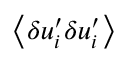<formula> <loc_0><loc_0><loc_500><loc_500>\, \left \langle { \delta u _ { i } ^ { \prime } \delta u _ { i } ^ { \prime } } \right \rangle</formula> 